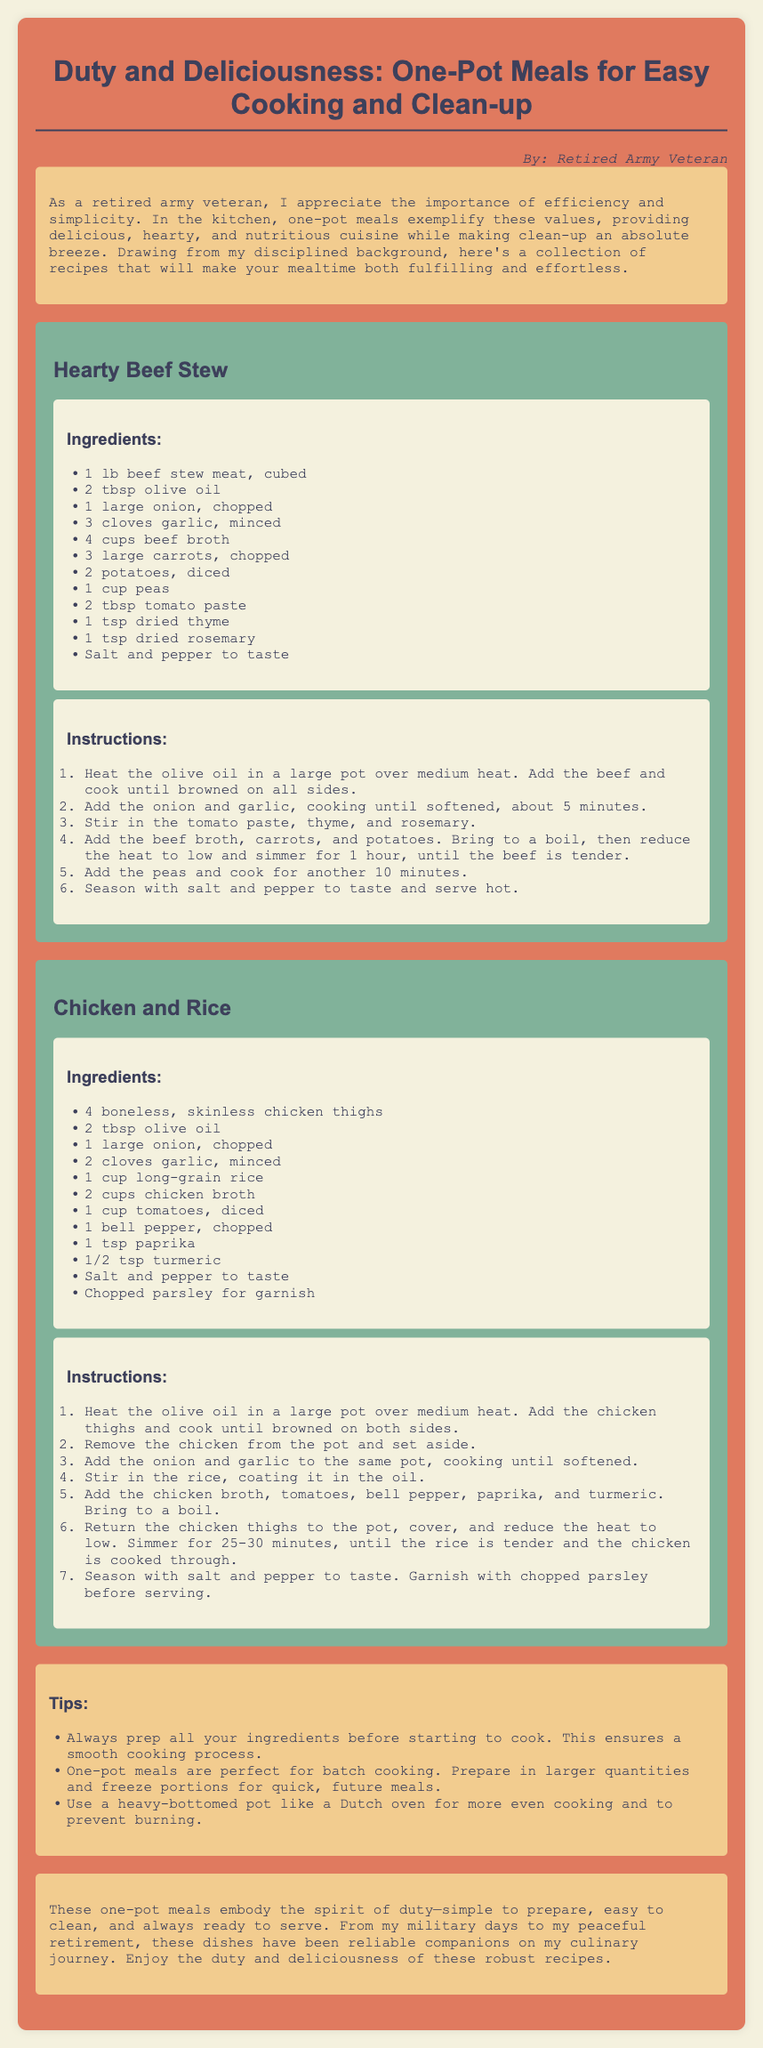what is the title of the document? The title is presented at the top of the document in a prominent font.
Answer: Duty and Deliciousness: One-Pot Meals for Easy Cooking and Clean-up who is the author of the recipes? The author is mentioned in the document, indicating the perspective from which the recipes are shared.
Answer: Retired Army Veteran how many recipes are included in the document? The document contains two clearly marked recipes listed one after the other.
Answer: 2 what is the main ingredient in the Hearty Beef Stew? The main ingredient is listed first in the ingredient list for that recipe.
Answer: beef stew meat what is the cooking time for the Chicken and Rice recipe? The cooking time is stated in the instructions section of the recipe.
Answer: 25-30 minutes what are the main vegetables used in Hearty Beef Stew? The vegetables are grouped together in the ingredient list for the stew recipe.
Answer: carrots, potatoes, peas what is a key tip mentioned for cooking one-pot meals? The tips section provides useful advice to enhance the cooking process.
Answer: prep all your ingredients what method of cooking is emphasized in the document? The document highlights a specific approach to meal preparation.
Answer: one-pot cooking what type of cuisine do these recipes represent? The recipes embody a general style of cooking that emphasizes efficiency and simplicity.
Answer: hearty, nutritious meals 